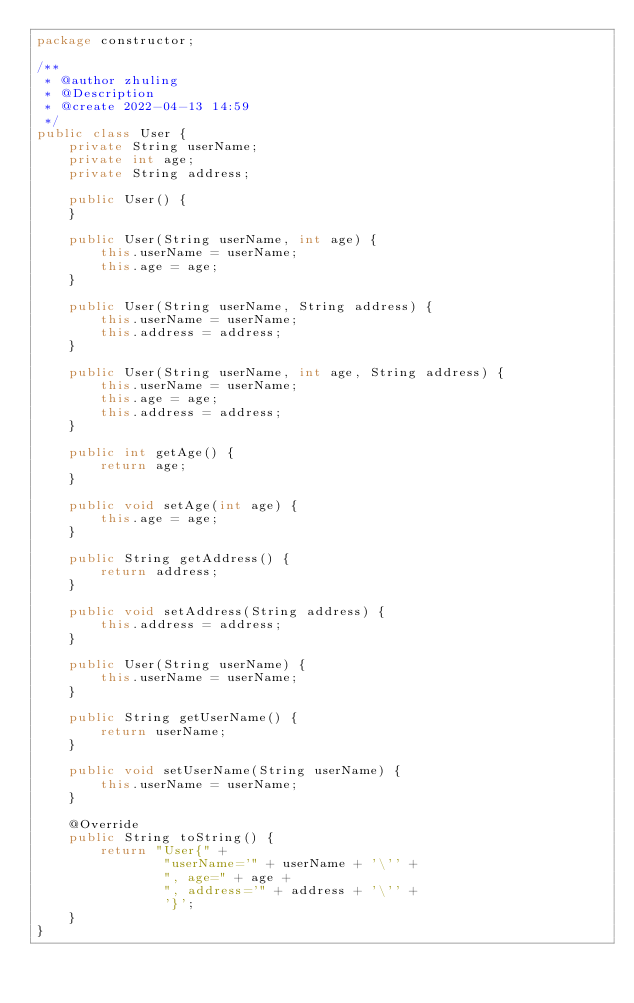Convert code to text. <code><loc_0><loc_0><loc_500><loc_500><_Java_>package constructor;

/**
 * @author zhuling
 * @Description
 * @create 2022-04-13 14:59
 */
public class User {
	private String userName;
	private int age;
	private String address;

	public User() {
	}

	public User(String userName, int age) {
		this.userName = userName;
		this.age = age;
	}

	public User(String userName, String address) {
		this.userName = userName;
		this.address = address;
	}

	public User(String userName, int age, String address) {
		this.userName = userName;
		this.age = age;
		this.address = address;
	}

	public int getAge() {
		return age;
	}

	public void setAge(int age) {
		this.age = age;
	}

	public String getAddress() {
		return address;
	}

	public void setAddress(String address) {
		this.address = address;
	}

	public User(String userName) {
		this.userName = userName;
	}

	public String getUserName() {
		return userName;
	}

	public void setUserName(String userName) {
		this.userName = userName;
	}

	@Override
	public String toString() {
		return "User{" +
				"userName='" + userName + '\'' +
				", age=" + age +
				", address='" + address + '\'' +
				'}';
	}
}
</code> 